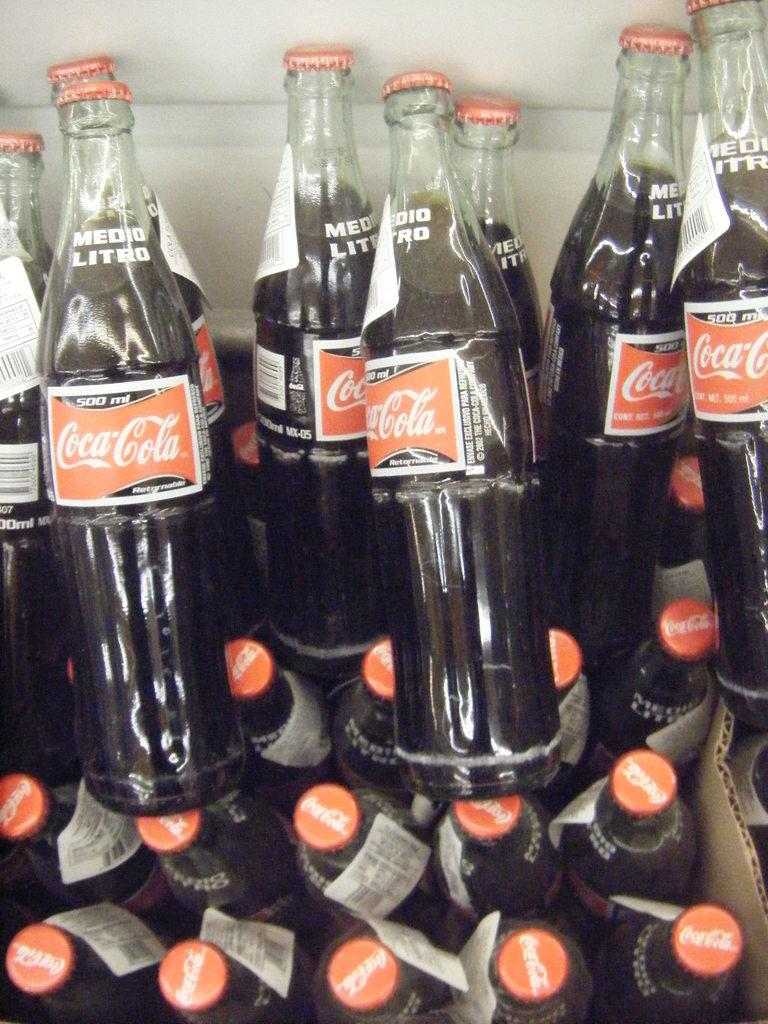Provide a one-sentence caption for the provided image. Glass bottles of Coca-Cola with barc code labels. 